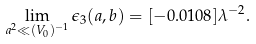Convert formula to latex. <formula><loc_0><loc_0><loc_500><loc_500>\lim _ { a ^ { 2 } \ll ( V _ { 0 } ) ^ { - 1 } } \epsilon _ { 3 } ( a , b ) = [ - 0 . 0 1 0 8 ] \lambda ^ { - 2 } .</formula> 